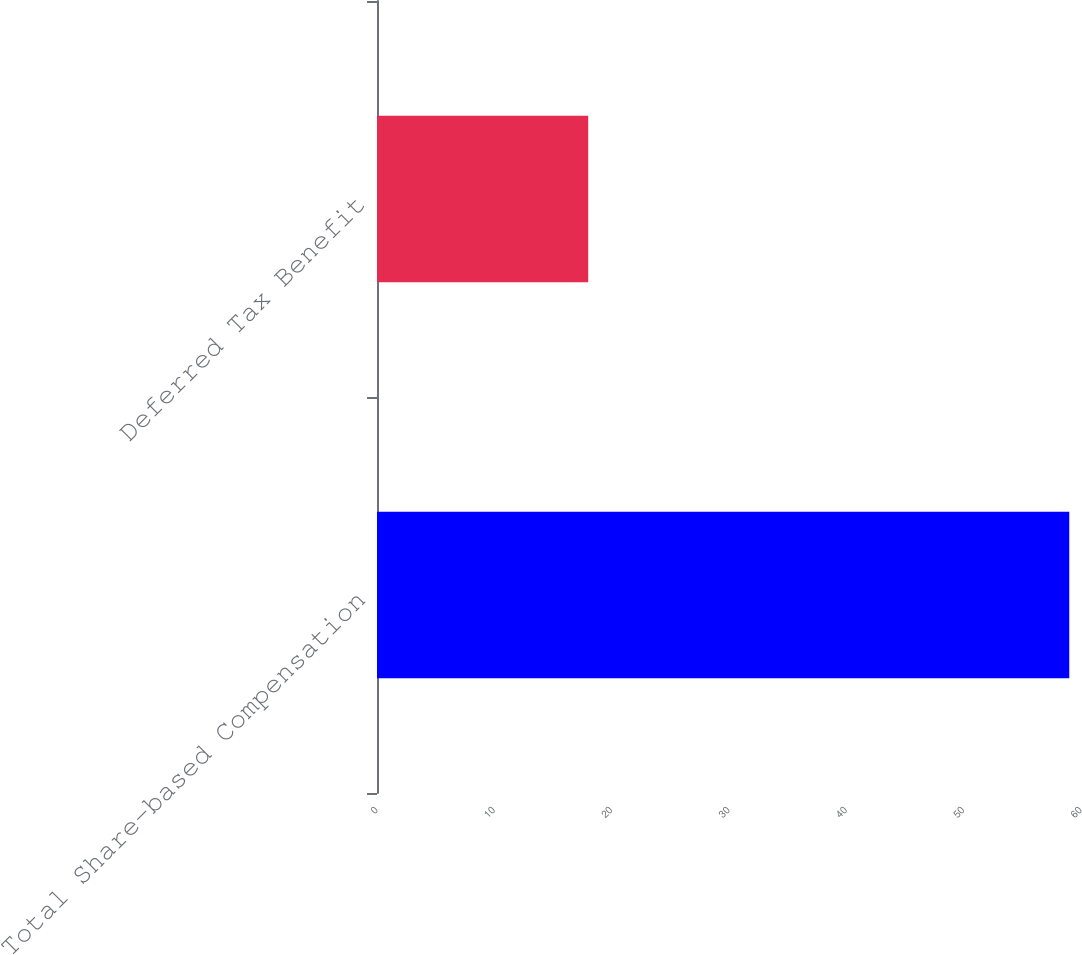Convert chart. <chart><loc_0><loc_0><loc_500><loc_500><bar_chart><fcel>Total Share-based Compensation<fcel>Deferred Tax Benefit<nl><fcel>59<fcel>18<nl></chart> 